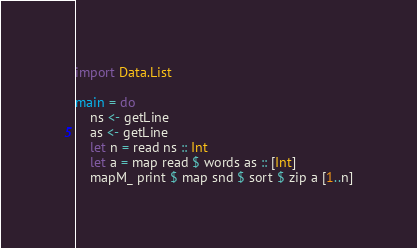<code> <loc_0><loc_0><loc_500><loc_500><_Haskell_>import Data.List

main = do
    ns <- getLine
    as <- getLine
    let n = read ns :: Int
    let a = map read $ words as :: [Int]
    mapM_ print $ map snd $ sort $ zip a [1..n]
</code> 